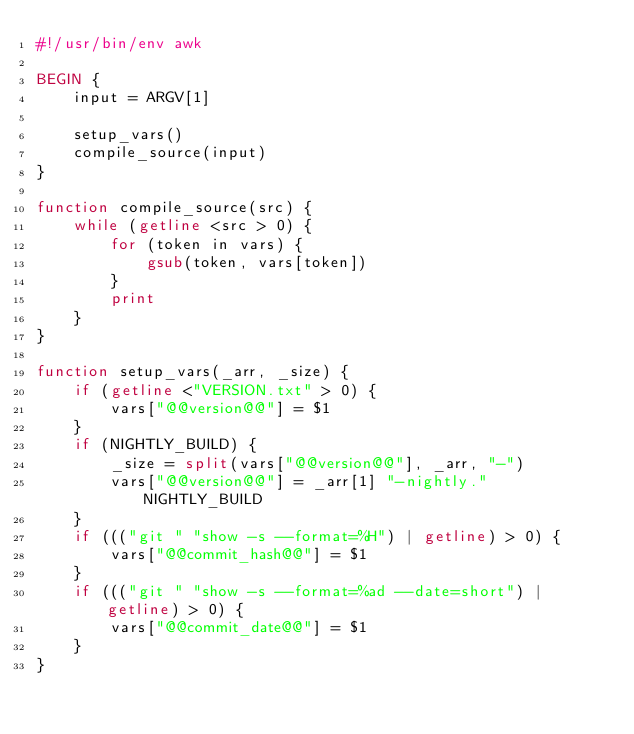<code> <loc_0><loc_0><loc_500><loc_500><_Awk_>#!/usr/bin/env awk

BEGIN {
    input = ARGV[1]

    setup_vars()
    compile_source(input)
}

function compile_source(src) {
    while (getline <src > 0) {
        for (token in vars) {
            gsub(token, vars[token])
        }
        print
    }
}

function setup_vars(_arr, _size) {
    if (getline <"VERSION.txt" > 0) {
        vars["@@version@@"] = $1
    }
    if (NIGHTLY_BUILD) {
        _size = split(vars["@@version@@"], _arr, "-")
        vars["@@version@@"] = _arr[1] "-nightly." NIGHTLY_BUILD
    }
    if ((("git " "show -s --format=%H") | getline) > 0) {
        vars["@@commit_hash@@"] = $1
    }
    if ((("git " "show -s --format=%ad --date=short") | getline) > 0) {
        vars["@@commit_date@@"] = $1
    }
}
</code> 